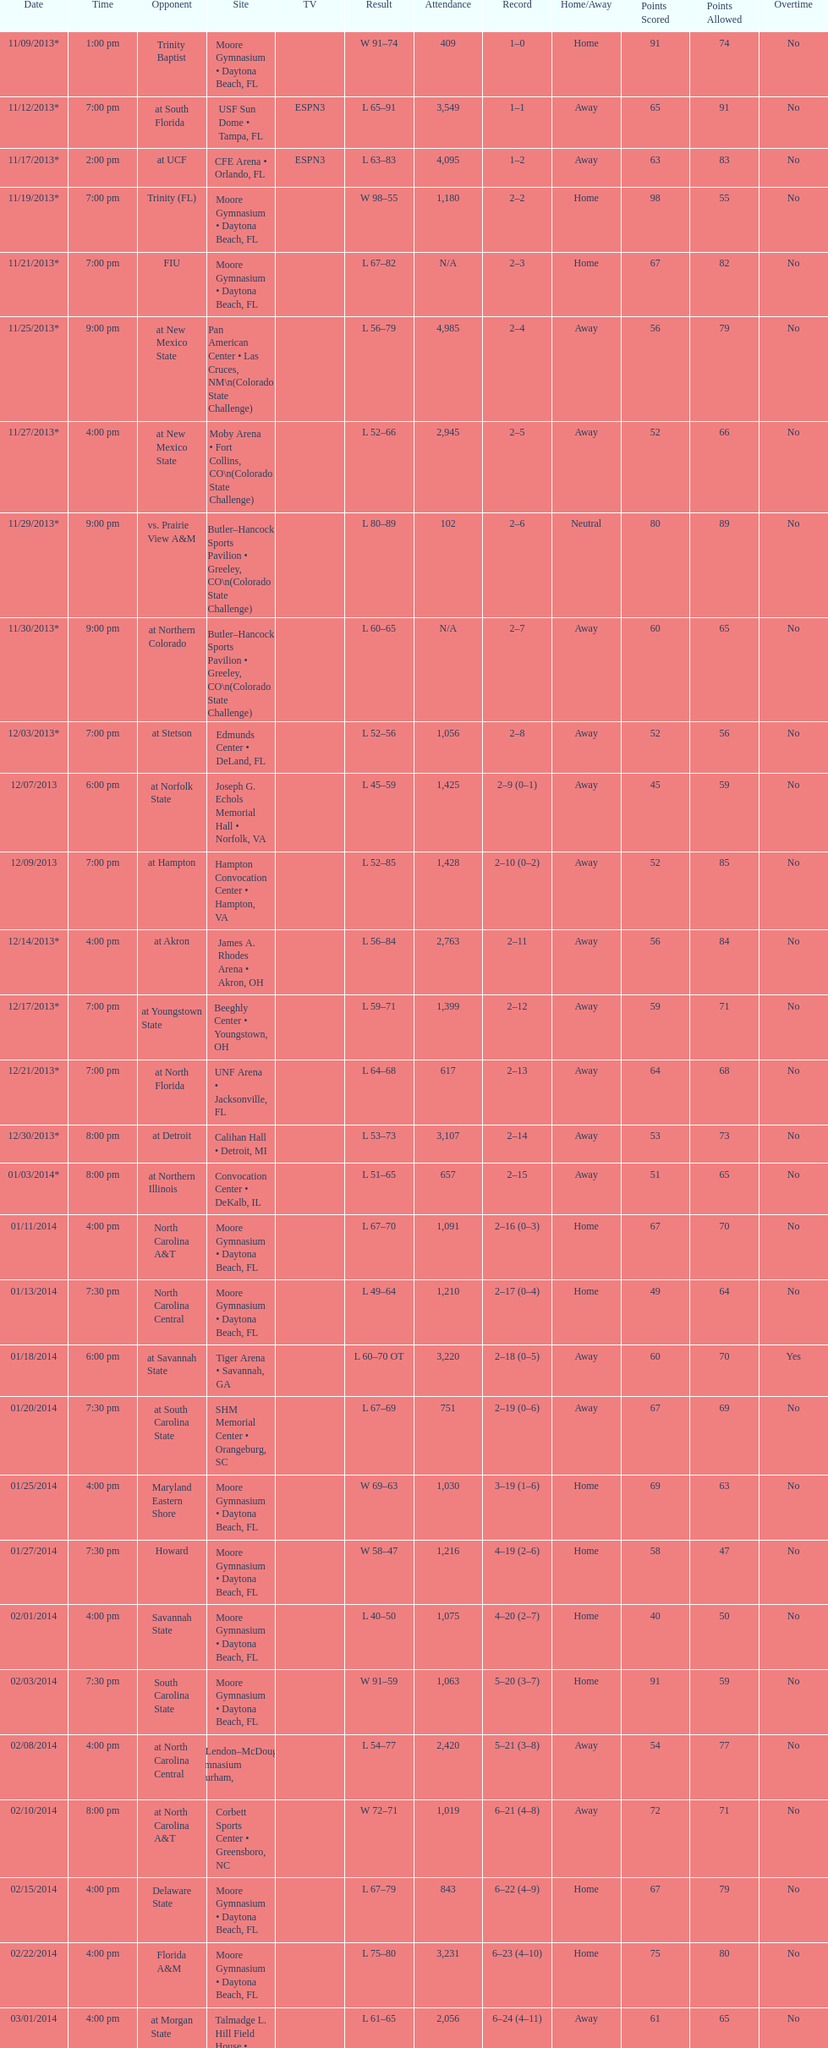How many teams had at most an attendance of 1,000? 6. 